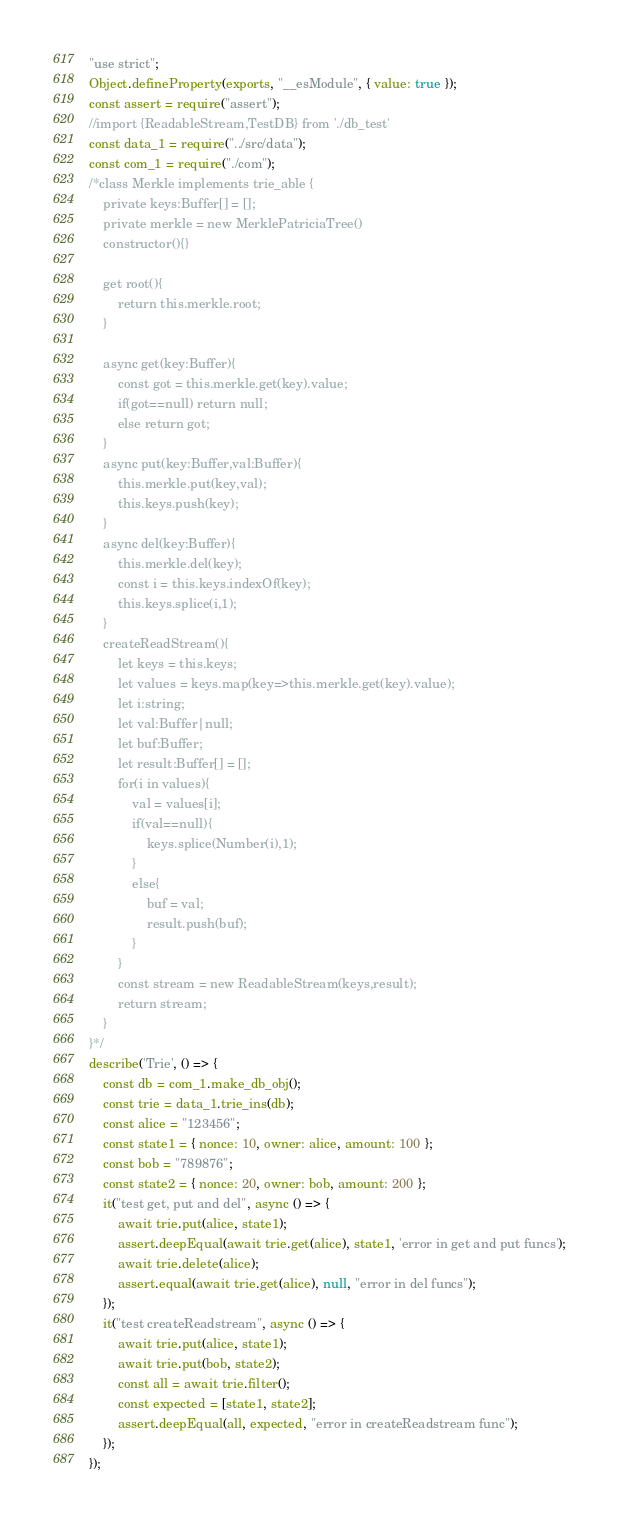Convert code to text. <code><loc_0><loc_0><loc_500><loc_500><_JavaScript_>"use strict";
Object.defineProperty(exports, "__esModule", { value: true });
const assert = require("assert");
//import {ReadableStream,TestDB} from './db_test'
const data_1 = require("../src/data");
const com_1 = require("./com");
/*class Merkle implements trie_able {
    private keys:Buffer[] = [];
    private merkle = new MerklePatriciaTree()
    constructor(){}

    get root(){
        return this.merkle.root;
    }

    async get(key:Buffer){
        const got = this.merkle.get(key).value;
        if(got==null) return null;
        else return got;
    }
    async put(key:Buffer,val:Buffer){
        this.merkle.put(key,val);
        this.keys.push(key);
    }
    async del(key:Buffer){
        this.merkle.del(key);
        const i = this.keys.indexOf(key);
        this.keys.splice(i,1);
    }
    createReadStream(){
        let keys = this.keys;
        let values = keys.map(key=>this.merkle.get(key).value);
        let i:string;
        let val:Buffer|null;
        let buf:Buffer;
        let result:Buffer[] = [];
        for(i in values){
            val = values[i];
            if(val==null){
                keys.splice(Number(i),1);
            }
            else{
                buf = val;
                result.push(buf);
            }
        }
        const stream = new ReadableStream(keys,result);
        return stream;
    }
}*/
describe('Trie', () => {
    const db = com_1.make_db_obj();
    const trie = data_1.trie_ins(db);
    const alice = "123456";
    const state1 = { nonce: 10, owner: alice, amount: 100 };
    const bob = "789876";
    const state2 = { nonce: 20, owner: bob, amount: 200 };
    it("test get, put and del", async () => {
        await trie.put(alice, state1);
        assert.deepEqual(await trie.get(alice), state1, 'error in get and put funcs');
        await trie.delete(alice);
        assert.equal(await trie.get(alice), null, "error in del funcs");
    });
    it("test createReadstream", async () => {
        await trie.put(alice, state1);
        await trie.put(bob, state2);
        const all = await trie.filter();
        const expected = [state1, state2];
        assert.deepEqual(all, expected, "error in createReadstream func");
    });
});
</code> 